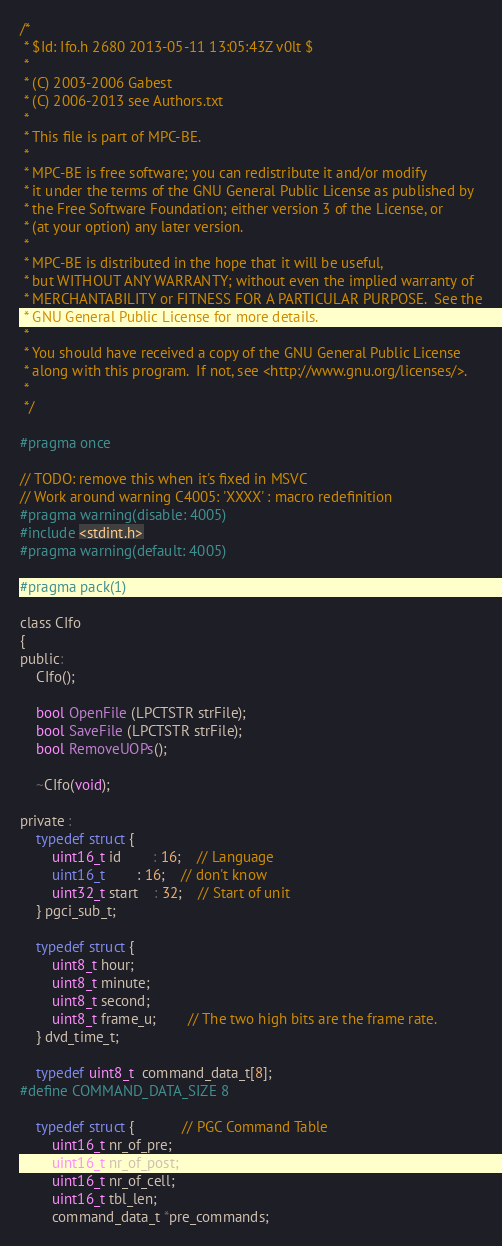<code> <loc_0><loc_0><loc_500><loc_500><_C_>/*
 * $Id: Ifo.h 2680 2013-05-11 13:05:43Z v0lt $
 *
 * (C) 2003-2006 Gabest
 * (C) 2006-2013 see Authors.txt
 *
 * This file is part of MPC-BE.
 *
 * MPC-BE is free software; you can redistribute it and/or modify
 * it under the terms of the GNU General Public License as published by
 * the Free Software Foundation; either version 3 of the License, or
 * (at your option) any later version.
 *
 * MPC-BE is distributed in the hope that it will be useful,
 * but WITHOUT ANY WARRANTY; without even the implied warranty of
 * MERCHANTABILITY or FITNESS FOR A PARTICULAR PURPOSE.  See the
 * GNU General Public License for more details.
 *
 * You should have received a copy of the GNU General Public License
 * along with this program.  If not, see <http://www.gnu.org/licenses/>.
 *
 */

#pragma once

// TODO: remove this when it's fixed in MSVC
// Work around warning C4005: 'XXXX' : macro redefinition
#pragma warning(disable: 4005)
#include <stdint.h>
#pragma warning(default: 4005)

#pragma pack(1)

class CIfo
{
public:
	CIfo();

	bool OpenFile (LPCTSTR strFile);
	bool SaveFile (LPCTSTR strFile);
	bool RemoveUOPs();

	~CIfo(void);

private :
	typedef struct {
		uint16_t id		: 16;	// Language
		uint16_t		: 16;	// don't know
		uint32_t start	: 32;	// Start of unit
	} pgci_sub_t;

	typedef struct {
		uint8_t hour;
		uint8_t minute;
		uint8_t second;
		uint8_t frame_u;		// The two high bits are the frame rate.
	} dvd_time_t;

	typedef uint8_t  command_data_t[8];
#define COMMAND_DATA_SIZE 8

	typedef struct {			// PGC Command Table
		uint16_t nr_of_pre;
		uint16_t nr_of_post;
		uint16_t nr_of_cell;
		uint16_t tbl_len;
		command_data_t *pre_commands;</code> 